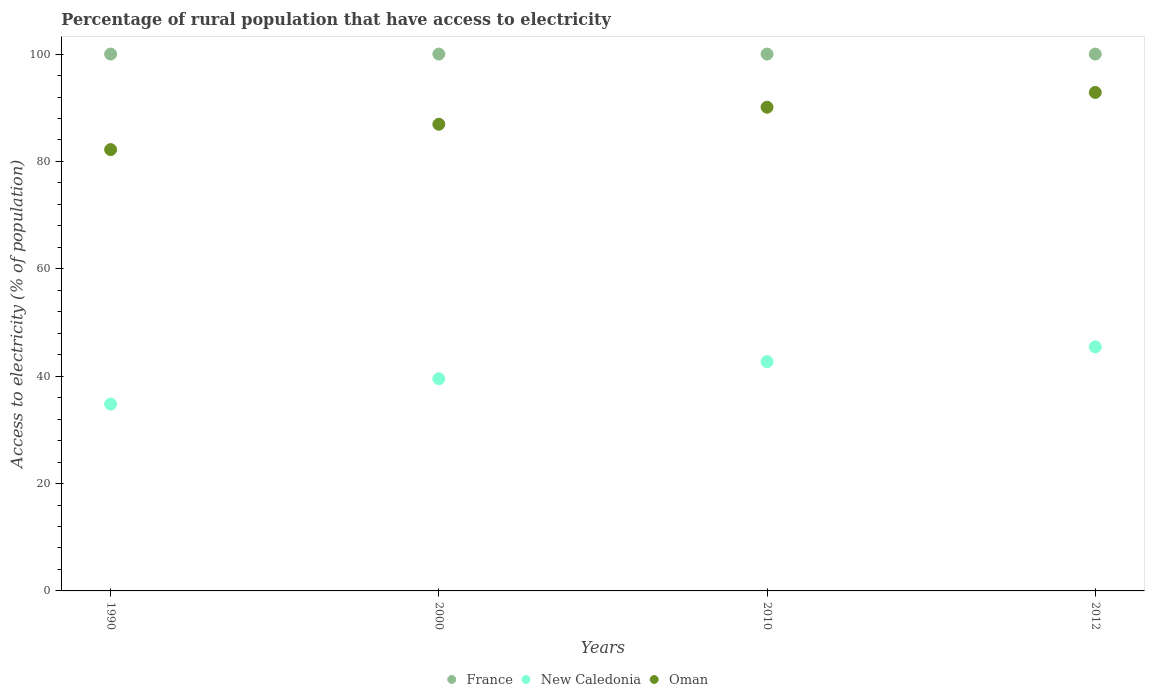How many different coloured dotlines are there?
Provide a succinct answer. 3. What is the percentage of rural population that have access to electricity in Oman in 1990?
Make the answer very short. 82.2. Across all years, what is the maximum percentage of rural population that have access to electricity in Oman?
Offer a terse response. 92.85. Across all years, what is the minimum percentage of rural population that have access to electricity in New Caledonia?
Offer a very short reply. 34.8. What is the total percentage of rural population that have access to electricity in Oman in the graph?
Offer a very short reply. 352.08. What is the difference between the percentage of rural population that have access to electricity in Oman in 2010 and that in 2012?
Provide a succinct answer. -2.75. What is the difference between the percentage of rural population that have access to electricity in France in 2000 and the percentage of rural population that have access to electricity in New Caledonia in 2010?
Your response must be concise. 57.3. What is the average percentage of rural population that have access to electricity in France per year?
Provide a succinct answer. 100. In the year 1990, what is the difference between the percentage of rural population that have access to electricity in France and percentage of rural population that have access to electricity in New Caledonia?
Keep it short and to the point. 65.2. What is the ratio of the percentage of rural population that have access to electricity in New Caledonia in 2000 to that in 2012?
Keep it short and to the point. 0.87. What is the difference between the highest and the second highest percentage of rural population that have access to electricity in France?
Provide a succinct answer. 0. In how many years, is the percentage of rural population that have access to electricity in Oman greater than the average percentage of rural population that have access to electricity in Oman taken over all years?
Provide a succinct answer. 2. Is the sum of the percentage of rural population that have access to electricity in New Caledonia in 1990 and 2000 greater than the maximum percentage of rural population that have access to electricity in France across all years?
Your answer should be compact. No. Is it the case that in every year, the sum of the percentage of rural population that have access to electricity in Oman and percentage of rural population that have access to electricity in France  is greater than the percentage of rural population that have access to electricity in New Caledonia?
Your answer should be very brief. Yes. Is the percentage of rural population that have access to electricity in Oman strictly less than the percentage of rural population that have access to electricity in France over the years?
Offer a very short reply. Yes. How many dotlines are there?
Provide a short and direct response. 3. How many years are there in the graph?
Give a very brief answer. 4. Are the values on the major ticks of Y-axis written in scientific E-notation?
Keep it short and to the point. No. Does the graph contain grids?
Ensure brevity in your answer.  No. How many legend labels are there?
Offer a terse response. 3. How are the legend labels stacked?
Your answer should be very brief. Horizontal. What is the title of the graph?
Your answer should be compact. Percentage of rural population that have access to electricity. What is the label or title of the X-axis?
Your response must be concise. Years. What is the label or title of the Y-axis?
Offer a very short reply. Access to electricity (% of population). What is the Access to electricity (% of population) of New Caledonia in 1990?
Provide a succinct answer. 34.8. What is the Access to electricity (% of population) of Oman in 1990?
Give a very brief answer. 82.2. What is the Access to electricity (% of population) in France in 2000?
Make the answer very short. 100. What is the Access to electricity (% of population) in New Caledonia in 2000?
Offer a terse response. 39.52. What is the Access to electricity (% of population) of Oman in 2000?
Provide a short and direct response. 86.93. What is the Access to electricity (% of population) of New Caledonia in 2010?
Ensure brevity in your answer.  42.7. What is the Access to electricity (% of population) of Oman in 2010?
Keep it short and to the point. 90.1. What is the Access to electricity (% of population) of New Caledonia in 2012?
Give a very brief answer. 45.45. What is the Access to electricity (% of population) of Oman in 2012?
Make the answer very short. 92.85. Across all years, what is the maximum Access to electricity (% of population) in New Caledonia?
Ensure brevity in your answer.  45.45. Across all years, what is the maximum Access to electricity (% of population) of Oman?
Your answer should be very brief. 92.85. Across all years, what is the minimum Access to electricity (% of population) in France?
Your answer should be compact. 100. Across all years, what is the minimum Access to electricity (% of population) of New Caledonia?
Offer a very short reply. 34.8. Across all years, what is the minimum Access to electricity (% of population) of Oman?
Provide a succinct answer. 82.2. What is the total Access to electricity (% of population) of New Caledonia in the graph?
Your answer should be compact. 162.47. What is the total Access to electricity (% of population) of Oman in the graph?
Give a very brief answer. 352.08. What is the difference between the Access to electricity (% of population) of France in 1990 and that in 2000?
Make the answer very short. 0. What is the difference between the Access to electricity (% of population) in New Caledonia in 1990 and that in 2000?
Ensure brevity in your answer.  -4.72. What is the difference between the Access to electricity (% of population) in Oman in 1990 and that in 2000?
Offer a terse response. -4.72. What is the difference between the Access to electricity (% of population) of New Caledonia in 1990 and that in 2010?
Give a very brief answer. -7.9. What is the difference between the Access to electricity (% of population) of Oman in 1990 and that in 2010?
Your answer should be compact. -7.9. What is the difference between the Access to electricity (% of population) in France in 1990 and that in 2012?
Your answer should be very brief. 0. What is the difference between the Access to electricity (% of population) in New Caledonia in 1990 and that in 2012?
Make the answer very short. -10.66. What is the difference between the Access to electricity (% of population) of Oman in 1990 and that in 2012?
Offer a terse response. -10.65. What is the difference between the Access to electricity (% of population) in New Caledonia in 2000 and that in 2010?
Provide a succinct answer. -3.18. What is the difference between the Access to electricity (% of population) in Oman in 2000 and that in 2010?
Provide a short and direct response. -3.17. What is the difference between the Access to electricity (% of population) of France in 2000 and that in 2012?
Ensure brevity in your answer.  0. What is the difference between the Access to electricity (% of population) of New Caledonia in 2000 and that in 2012?
Your response must be concise. -5.93. What is the difference between the Access to electricity (% of population) of Oman in 2000 and that in 2012?
Give a very brief answer. -5.93. What is the difference between the Access to electricity (% of population) of France in 2010 and that in 2012?
Make the answer very short. 0. What is the difference between the Access to electricity (% of population) in New Caledonia in 2010 and that in 2012?
Give a very brief answer. -2.75. What is the difference between the Access to electricity (% of population) of Oman in 2010 and that in 2012?
Give a very brief answer. -2.75. What is the difference between the Access to electricity (% of population) of France in 1990 and the Access to electricity (% of population) of New Caledonia in 2000?
Provide a short and direct response. 60.48. What is the difference between the Access to electricity (% of population) in France in 1990 and the Access to electricity (% of population) in Oman in 2000?
Provide a short and direct response. 13.07. What is the difference between the Access to electricity (% of population) in New Caledonia in 1990 and the Access to electricity (% of population) in Oman in 2000?
Keep it short and to the point. -52.13. What is the difference between the Access to electricity (% of population) of France in 1990 and the Access to electricity (% of population) of New Caledonia in 2010?
Offer a very short reply. 57.3. What is the difference between the Access to electricity (% of population) of France in 1990 and the Access to electricity (% of population) of Oman in 2010?
Make the answer very short. 9.9. What is the difference between the Access to electricity (% of population) of New Caledonia in 1990 and the Access to electricity (% of population) of Oman in 2010?
Your answer should be very brief. -55.3. What is the difference between the Access to electricity (% of population) in France in 1990 and the Access to electricity (% of population) in New Caledonia in 2012?
Your response must be concise. 54.55. What is the difference between the Access to electricity (% of population) of France in 1990 and the Access to electricity (% of population) of Oman in 2012?
Your answer should be compact. 7.15. What is the difference between the Access to electricity (% of population) in New Caledonia in 1990 and the Access to electricity (% of population) in Oman in 2012?
Provide a short and direct response. -58.06. What is the difference between the Access to electricity (% of population) in France in 2000 and the Access to electricity (% of population) in New Caledonia in 2010?
Keep it short and to the point. 57.3. What is the difference between the Access to electricity (% of population) in New Caledonia in 2000 and the Access to electricity (% of population) in Oman in 2010?
Ensure brevity in your answer.  -50.58. What is the difference between the Access to electricity (% of population) in France in 2000 and the Access to electricity (% of population) in New Caledonia in 2012?
Your answer should be compact. 54.55. What is the difference between the Access to electricity (% of population) in France in 2000 and the Access to electricity (% of population) in Oman in 2012?
Give a very brief answer. 7.15. What is the difference between the Access to electricity (% of population) in New Caledonia in 2000 and the Access to electricity (% of population) in Oman in 2012?
Offer a very short reply. -53.33. What is the difference between the Access to electricity (% of population) of France in 2010 and the Access to electricity (% of population) of New Caledonia in 2012?
Your response must be concise. 54.55. What is the difference between the Access to electricity (% of population) of France in 2010 and the Access to electricity (% of population) of Oman in 2012?
Offer a very short reply. 7.15. What is the difference between the Access to electricity (% of population) of New Caledonia in 2010 and the Access to electricity (% of population) of Oman in 2012?
Offer a terse response. -50.15. What is the average Access to electricity (% of population) of New Caledonia per year?
Give a very brief answer. 40.62. What is the average Access to electricity (% of population) in Oman per year?
Provide a short and direct response. 88.02. In the year 1990, what is the difference between the Access to electricity (% of population) in France and Access to electricity (% of population) in New Caledonia?
Keep it short and to the point. 65.2. In the year 1990, what is the difference between the Access to electricity (% of population) in France and Access to electricity (% of population) in Oman?
Offer a very short reply. 17.8. In the year 1990, what is the difference between the Access to electricity (% of population) in New Caledonia and Access to electricity (% of population) in Oman?
Your answer should be very brief. -47.41. In the year 2000, what is the difference between the Access to electricity (% of population) in France and Access to electricity (% of population) in New Caledonia?
Give a very brief answer. 60.48. In the year 2000, what is the difference between the Access to electricity (% of population) in France and Access to electricity (% of population) in Oman?
Your answer should be compact. 13.07. In the year 2000, what is the difference between the Access to electricity (% of population) of New Caledonia and Access to electricity (% of population) of Oman?
Make the answer very short. -47.41. In the year 2010, what is the difference between the Access to electricity (% of population) in France and Access to electricity (% of population) in New Caledonia?
Give a very brief answer. 57.3. In the year 2010, what is the difference between the Access to electricity (% of population) in New Caledonia and Access to electricity (% of population) in Oman?
Make the answer very short. -47.4. In the year 2012, what is the difference between the Access to electricity (% of population) in France and Access to electricity (% of population) in New Caledonia?
Offer a very short reply. 54.55. In the year 2012, what is the difference between the Access to electricity (% of population) in France and Access to electricity (% of population) in Oman?
Your answer should be compact. 7.15. In the year 2012, what is the difference between the Access to electricity (% of population) in New Caledonia and Access to electricity (% of population) in Oman?
Your answer should be very brief. -47.4. What is the ratio of the Access to electricity (% of population) in New Caledonia in 1990 to that in 2000?
Provide a succinct answer. 0.88. What is the ratio of the Access to electricity (% of population) in Oman in 1990 to that in 2000?
Your answer should be very brief. 0.95. What is the ratio of the Access to electricity (% of population) of New Caledonia in 1990 to that in 2010?
Make the answer very short. 0.81. What is the ratio of the Access to electricity (% of population) in Oman in 1990 to that in 2010?
Your response must be concise. 0.91. What is the ratio of the Access to electricity (% of population) of New Caledonia in 1990 to that in 2012?
Your answer should be very brief. 0.77. What is the ratio of the Access to electricity (% of population) of Oman in 1990 to that in 2012?
Keep it short and to the point. 0.89. What is the ratio of the Access to electricity (% of population) of France in 2000 to that in 2010?
Give a very brief answer. 1. What is the ratio of the Access to electricity (% of population) in New Caledonia in 2000 to that in 2010?
Your response must be concise. 0.93. What is the ratio of the Access to electricity (% of population) of Oman in 2000 to that in 2010?
Offer a very short reply. 0.96. What is the ratio of the Access to electricity (% of population) in New Caledonia in 2000 to that in 2012?
Keep it short and to the point. 0.87. What is the ratio of the Access to electricity (% of population) in Oman in 2000 to that in 2012?
Provide a short and direct response. 0.94. What is the ratio of the Access to electricity (% of population) in France in 2010 to that in 2012?
Provide a short and direct response. 1. What is the ratio of the Access to electricity (% of population) of New Caledonia in 2010 to that in 2012?
Offer a very short reply. 0.94. What is the ratio of the Access to electricity (% of population) in Oman in 2010 to that in 2012?
Your response must be concise. 0.97. What is the difference between the highest and the second highest Access to electricity (% of population) in New Caledonia?
Your answer should be very brief. 2.75. What is the difference between the highest and the second highest Access to electricity (% of population) in Oman?
Your answer should be very brief. 2.75. What is the difference between the highest and the lowest Access to electricity (% of population) of France?
Provide a short and direct response. 0. What is the difference between the highest and the lowest Access to electricity (% of population) of New Caledonia?
Provide a succinct answer. 10.66. What is the difference between the highest and the lowest Access to electricity (% of population) in Oman?
Give a very brief answer. 10.65. 